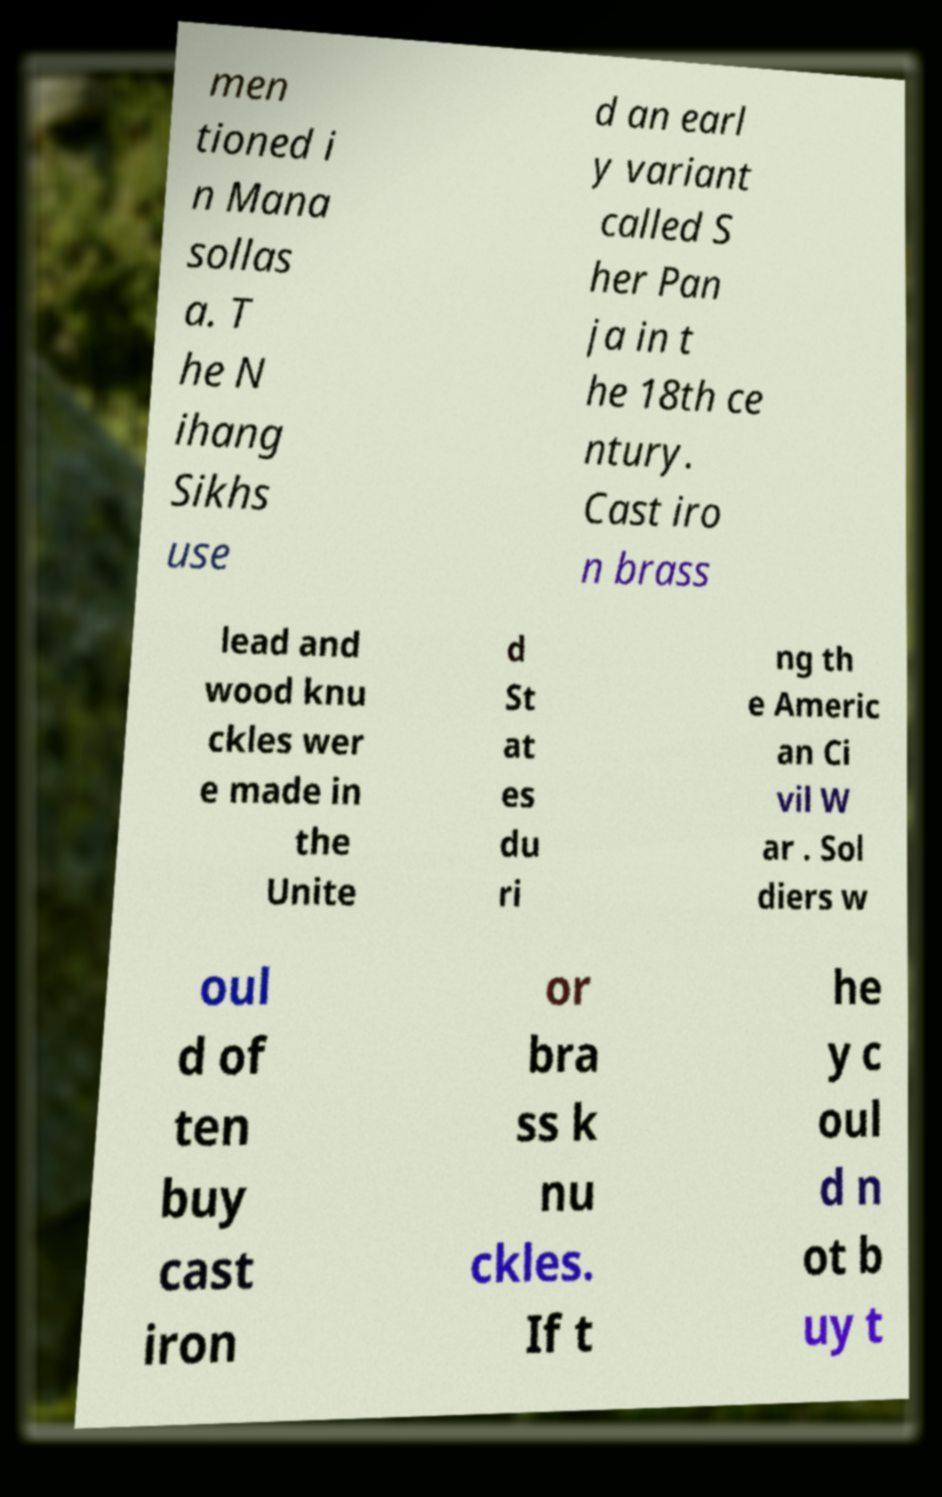Could you assist in decoding the text presented in this image and type it out clearly? men tioned i n Mana sollas a. T he N ihang Sikhs use d an earl y variant called S her Pan ja in t he 18th ce ntury. Cast iro n brass lead and wood knu ckles wer e made in the Unite d St at es du ri ng th e Americ an Ci vil W ar . Sol diers w oul d of ten buy cast iron or bra ss k nu ckles. If t he y c oul d n ot b uy t 